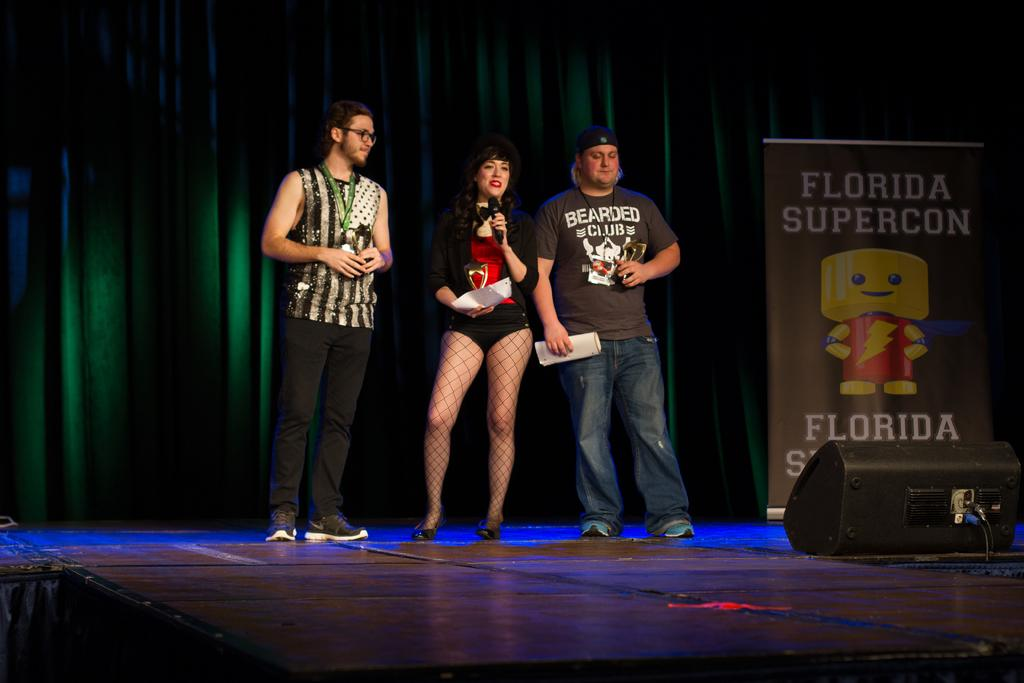Provide a one-sentence caption for the provided image. Two men with a woman in the middle are on a stage with a sign that says Florida Supercon on the right. 